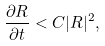<formula> <loc_0><loc_0><loc_500><loc_500>\frac { \partial R } { \partial t } < C | R | ^ { 2 } ,</formula> 